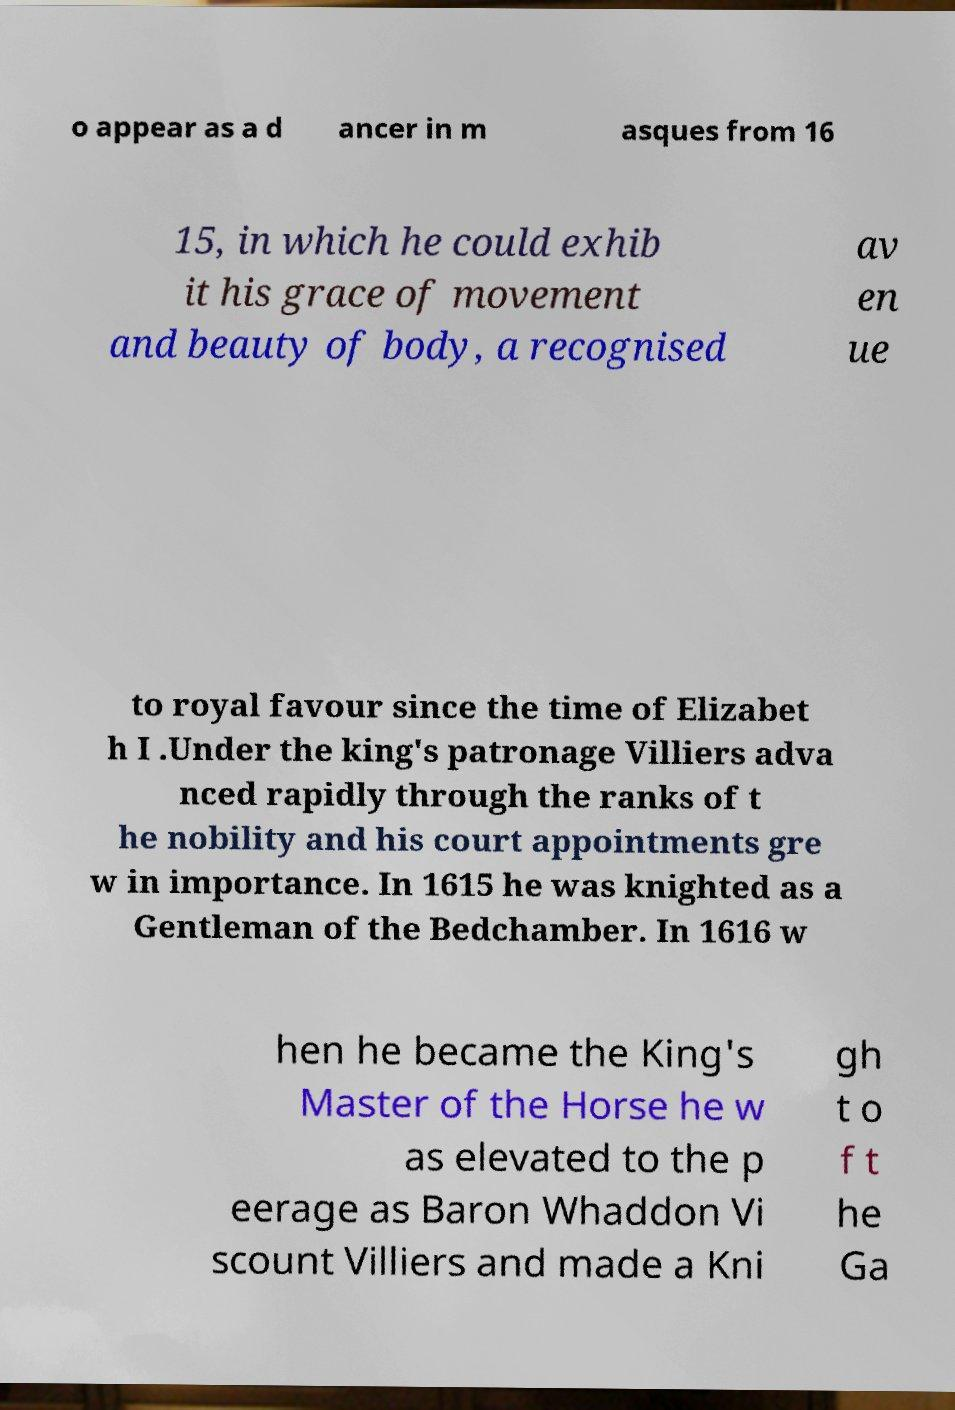Can you accurately transcribe the text from the provided image for me? o appear as a d ancer in m asques from 16 15, in which he could exhib it his grace of movement and beauty of body, a recognised av en ue to royal favour since the time of Elizabet h I .Under the king's patronage Villiers adva nced rapidly through the ranks of t he nobility and his court appointments gre w in importance. In 1615 he was knighted as a Gentleman of the Bedchamber. In 1616 w hen he became the King's Master of the Horse he w as elevated to the p eerage as Baron Whaddon Vi scount Villiers and made a Kni gh t o f t he Ga 